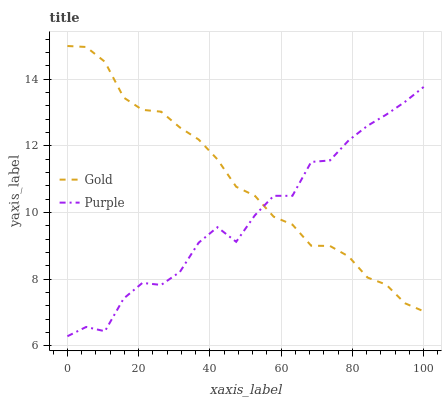Does Purple have the minimum area under the curve?
Answer yes or no. Yes. Does Gold have the maximum area under the curve?
Answer yes or no. Yes. Does Gold have the minimum area under the curve?
Answer yes or no. No. Is Gold the smoothest?
Answer yes or no. Yes. Is Purple the roughest?
Answer yes or no. Yes. Is Gold the roughest?
Answer yes or no. No. Does Purple have the lowest value?
Answer yes or no. Yes. Does Gold have the lowest value?
Answer yes or no. No. Does Gold have the highest value?
Answer yes or no. Yes. Does Purple intersect Gold?
Answer yes or no. Yes. Is Purple less than Gold?
Answer yes or no. No. Is Purple greater than Gold?
Answer yes or no. No. 